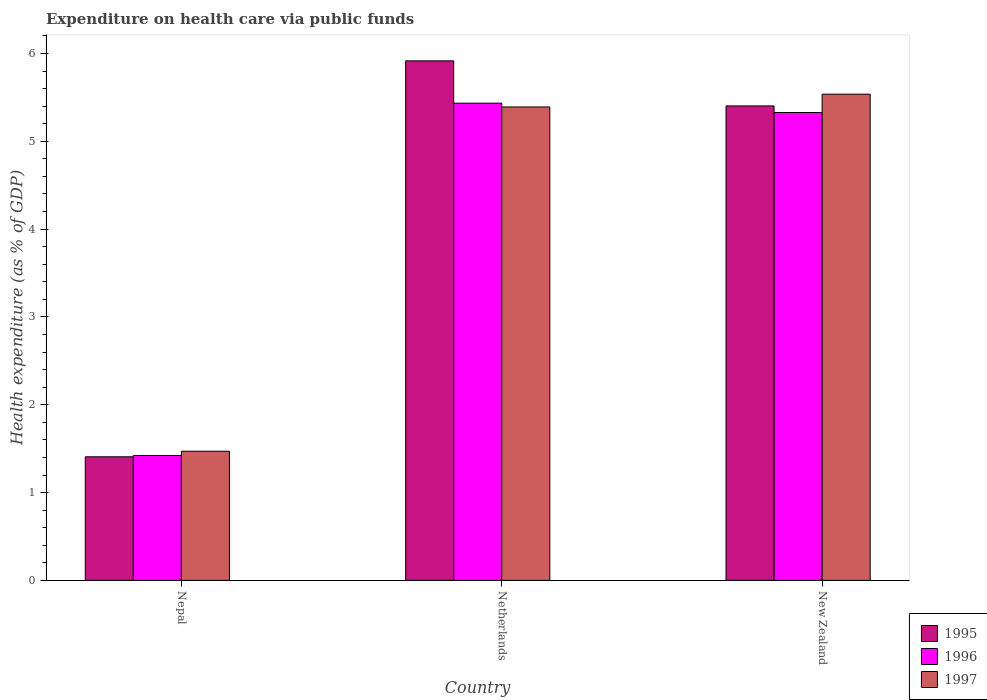How many different coloured bars are there?
Provide a succinct answer. 3. How many groups of bars are there?
Make the answer very short. 3. Are the number of bars per tick equal to the number of legend labels?
Your response must be concise. Yes. Are the number of bars on each tick of the X-axis equal?
Your response must be concise. Yes. How many bars are there on the 2nd tick from the left?
Ensure brevity in your answer.  3. What is the label of the 3rd group of bars from the left?
Offer a very short reply. New Zealand. In how many cases, is the number of bars for a given country not equal to the number of legend labels?
Ensure brevity in your answer.  0. What is the expenditure made on health care in 1996 in New Zealand?
Give a very brief answer. 5.33. Across all countries, what is the maximum expenditure made on health care in 1995?
Your answer should be compact. 5.92. Across all countries, what is the minimum expenditure made on health care in 1995?
Keep it short and to the point. 1.41. In which country was the expenditure made on health care in 1995 minimum?
Give a very brief answer. Nepal. What is the total expenditure made on health care in 1996 in the graph?
Offer a very short reply. 12.18. What is the difference between the expenditure made on health care in 1996 in Netherlands and that in New Zealand?
Ensure brevity in your answer.  0.11. What is the difference between the expenditure made on health care in 1997 in Nepal and the expenditure made on health care in 1996 in New Zealand?
Make the answer very short. -3.86. What is the average expenditure made on health care in 1997 per country?
Give a very brief answer. 4.13. What is the difference between the expenditure made on health care of/in 1996 and expenditure made on health care of/in 1997 in Netherlands?
Offer a very short reply. 0.04. In how many countries, is the expenditure made on health care in 1997 greater than 3.4 %?
Offer a very short reply. 2. What is the ratio of the expenditure made on health care in 1995 in Nepal to that in New Zealand?
Offer a very short reply. 0.26. Is the expenditure made on health care in 1995 in Netherlands less than that in New Zealand?
Offer a terse response. No. Is the difference between the expenditure made on health care in 1996 in Nepal and Netherlands greater than the difference between the expenditure made on health care in 1997 in Nepal and Netherlands?
Provide a short and direct response. No. What is the difference between the highest and the second highest expenditure made on health care in 1997?
Offer a very short reply. -3.92. What is the difference between the highest and the lowest expenditure made on health care in 1995?
Keep it short and to the point. 4.51. Is the sum of the expenditure made on health care in 1997 in Nepal and Netherlands greater than the maximum expenditure made on health care in 1996 across all countries?
Offer a terse response. Yes. What does the 1st bar from the right in Netherlands represents?
Ensure brevity in your answer.  1997. How many bars are there?
Provide a succinct answer. 9. How many countries are there in the graph?
Your answer should be very brief. 3. What is the difference between two consecutive major ticks on the Y-axis?
Give a very brief answer. 1. Does the graph contain any zero values?
Offer a terse response. No. Where does the legend appear in the graph?
Your answer should be compact. Bottom right. How many legend labels are there?
Give a very brief answer. 3. What is the title of the graph?
Ensure brevity in your answer.  Expenditure on health care via public funds. What is the label or title of the Y-axis?
Offer a very short reply. Health expenditure (as % of GDP). What is the Health expenditure (as % of GDP) in 1995 in Nepal?
Keep it short and to the point. 1.41. What is the Health expenditure (as % of GDP) of 1996 in Nepal?
Your response must be concise. 1.42. What is the Health expenditure (as % of GDP) of 1997 in Nepal?
Give a very brief answer. 1.47. What is the Health expenditure (as % of GDP) of 1995 in Netherlands?
Provide a short and direct response. 5.92. What is the Health expenditure (as % of GDP) of 1996 in Netherlands?
Offer a terse response. 5.43. What is the Health expenditure (as % of GDP) in 1997 in Netherlands?
Offer a very short reply. 5.39. What is the Health expenditure (as % of GDP) of 1995 in New Zealand?
Offer a very short reply. 5.4. What is the Health expenditure (as % of GDP) of 1996 in New Zealand?
Provide a short and direct response. 5.33. What is the Health expenditure (as % of GDP) of 1997 in New Zealand?
Your answer should be very brief. 5.54. Across all countries, what is the maximum Health expenditure (as % of GDP) of 1995?
Your response must be concise. 5.92. Across all countries, what is the maximum Health expenditure (as % of GDP) in 1996?
Provide a succinct answer. 5.43. Across all countries, what is the maximum Health expenditure (as % of GDP) in 1997?
Your answer should be very brief. 5.54. Across all countries, what is the minimum Health expenditure (as % of GDP) of 1995?
Offer a very short reply. 1.41. Across all countries, what is the minimum Health expenditure (as % of GDP) in 1996?
Your response must be concise. 1.42. Across all countries, what is the minimum Health expenditure (as % of GDP) in 1997?
Keep it short and to the point. 1.47. What is the total Health expenditure (as % of GDP) of 1995 in the graph?
Make the answer very short. 12.73. What is the total Health expenditure (as % of GDP) of 1996 in the graph?
Your response must be concise. 12.18. What is the total Health expenditure (as % of GDP) of 1997 in the graph?
Keep it short and to the point. 12.4. What is the difference between the Health expenditure (as % of GDP) in 1995 in Nepal and that in Netherlands?
Your answer should be very brief. -4.51. What is the difference between the Health expenditure (as % of GDP) of 1996 in Nepal and that in Netherlands?
Your answer should be compact. -4.01. What is the difference between the Health expenditure (as % of GDP) of 1997 in Nepal and that in Netherlands?
Ensure brevity in your answer.  -3.92. What is the difference between the Health expenditure (as % of GDP) of 1995 in Nepal and that in New Zealand?
Your response must be concise. -4. What is the difference between the Health expenditure (as % of GDP) of 1996 in Nepal and that in New Zealand?
Provide a succinct answer. -3.91. What is the difference between the Health expenditure (as % of GDP) in 1997 in Nepal and that in New Zealand?
Your answer should be very brief. -4.07. What is the difference between the Health expenditure (as % of GDP) of 1995 in Netherlands and that in New Zealand?
Ensure brevity in your answer.  0.51. What is the difference between the Health expenditure (as % of GDP) in 1996 in Netherlands and that in New Zealand?
Ensure brevity in your answer.  0.11. What is the difference between the Health expenditure (as % of GDP) in 1997 in Netherlands and that in New Zealand?
Offer a terse response. -0.15. What is the difference between the Health expenditure (as % of GDP) in 1995 in Nepal and the Health expenditure (as % of GDP) in 1996 in Netherlands?
Your answer should be compact. -4.03. What is the difference between the Health expenditure (as % of GDP) in 1995 in Nepal and the Health expenditure (as % of GDP) in 1997 in Netherlands?
Provide a short and direct response. -3.98. What is the difference between the Health expenditure (as % of GDP) in 1996 in Nepal and the Health expenditure (as % of GDP) in 1997 in Netherlands?
Give a very brief answer. -3.97. What is the difference between the Health expenditure (as % of GDP) of 1995 in Nepal and the Health expenditure (as % of GDP) of 1996 in New Zealand?
Ensure brevity in your answer.  -3.92. What is the difference between the Health expenditure (as % of GDP) of 1995 in Nepal and the Health expenditure (as % of GDP) of 1997 in New Zealand?
Make the answer very short. -4.13. What is the difference between the Health expenditure (as % of GDP) in 1996 in Nepal and the Health expenditure (as % of GDP) in 1997 in New Zealand?
Make the answer very short. -4.11. What is the difference between the Health expenditure (as % of GDP) in 1995 in Netherlands and the Health expenditure (as % of GDP) in 1996 in New Zealand?
Give a very brief answer. 0.59. What is the difference between the Health expenditure (as % of GDP) of 1995 in Netherlands and the Health expenditure (as % of GDP) of 1997 in New Zealand?
Offer a terse response. 0.38. What is the difference between the Health expenditure (as % of GDP) of 1996 in Netherlands and the Health expenditure (as % of GDP) of 1997 in New Zealand?
Offer a terse response. -0.1. What is the average Health expenditure (as % of GDP) of 1995 per country?
Your response must be concise. 4.24. What is the average Health expenditure (as % of GDP) of 1996 per country?
Your answer should be compact. 4.06. What is the average Health expenditure (as % of GDP) in 1997 per country?
Provide a succinct answer. 4.13. What is the difference between the Health expenditure (as % of GDP) of 1995 and Health expenditure (as % of GDP) of 1996 in Nepal?
Provide a short and direct response. -0.01. What is the difference between the Health expenditure (as % of GDP) of 1995 and Health expenditure (as % of GDP) of 1997 in Nepal?
Your answer should be very brief. -0.06. What is the difference between the Health expenditure (as % of GDP) in 1996 and Health expenditure (as % of GDP) in 1997 in Nepal?
Keep it short and to the point. -0.05. What is the difference between the Health expenditure (as % of GDP) of 1995 and Health expenditure (as % of GDP) of 1996 in Netherlands?
Make the answer very short. 0.48. What is the difference between the Health expenditure (as % of GDP) in 1995 and Health expenditure (as % of GDP) in 1997 in Netherlands?
Your answer should be compact. 0.53. What is the difference between the Health expenditure (as % of GDP) of 1996 and Health expenditure (as % of GDP) of 1997 in Netherlands?
Make the answer very short. 0.04. What is the difference between the Health expenditure (as % of GDP) of 1995 and Health expenditure (as % of GDP) of 1996 in New Zealand?
Provide a short and direct response. 0.08. What is the difference between the Health expenditure (as % of GDP) of 1995 and Health expenditure (as % of GDP) of 1997 in New Zealand?
Your answer should be very brief. -0.13. What is the difference between the Health expenditure (as % of GDP) in 1996 and Health expenditure (as % of GDP) in 1997 in New Zealand?
Provide a short and direct response. -0.21. What is the ratio of the Health expenditure (as % of GDP) in 1995 in Nepal to that in Netherlands?
Provide a succinct answer. 0.24. What is the ratio of the Health expenditure (as % of GDP) of 1996 in Nepal to that in Netherlands?
Offer a very short reply. 0.26. What is the ratio of the Health expenditure (as % of GDP) of 1997 in Nepal to that in Netherlands?
Your response must be concise. 0.27. What is the ratio of the Health expenditure (as % of GDP) in 1995 in Nepal to that in New Zealand?
Provide a succinct answer. 0.26. What is the ratio of the Health expenditure (as % of GDP) of 1996 in Nepal to that in New Zealand?
Provide a succinct answer. 0.27. What is the ratio of the Health expenditure (as % of GDP) of 1997 in Nepal to that in New Zealand?
Provide a succinct answer. 0.27. What is the ratio of the Health expenditure (as % of GDP) in 1995 in Netherlands to that in New Zealand?
Offer a very short reply. 1.09. What is the ratio of the Health expenditure (as % of GDP) of 1997 in Netherlands to that in New Zealand?
Your answer should be very brief. 0.97. What is the difference between the highest and the second highest Health expenditure (as % of GDP) of 1995?
Your answer should be compact. 0.51. What is the difference between the highest and the second highest Health expenditure (as % of GDP) in 1996?
Make the answer very short. 0.11. What is the difference between the highest and the second highest Health expenditure (as % of GDP) in 1997?
Make the answer very short. 0.15. What is the difference between the highest and the lowest Health expenditure (as % of GDP) of 1995?
Ensure brevity in your answer.  4.51. What is the difference between the highest and the lowest Health expenditure (as % of GDP) in 1996?
Provide a succinct answer. 4.01. What is the difference between the highest and the lowest Health expenditure (as % of GDP) in 1997?
Keep it short and to the point. 4.07. 